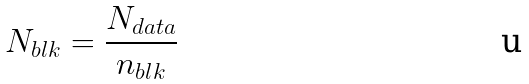Convert formula to latex. <formula><loc_0><loc_0><loc_500><loc_500>N _ { b l k } = \frac { N _ { d a t a } } { n _ { b l k } }</formula> 